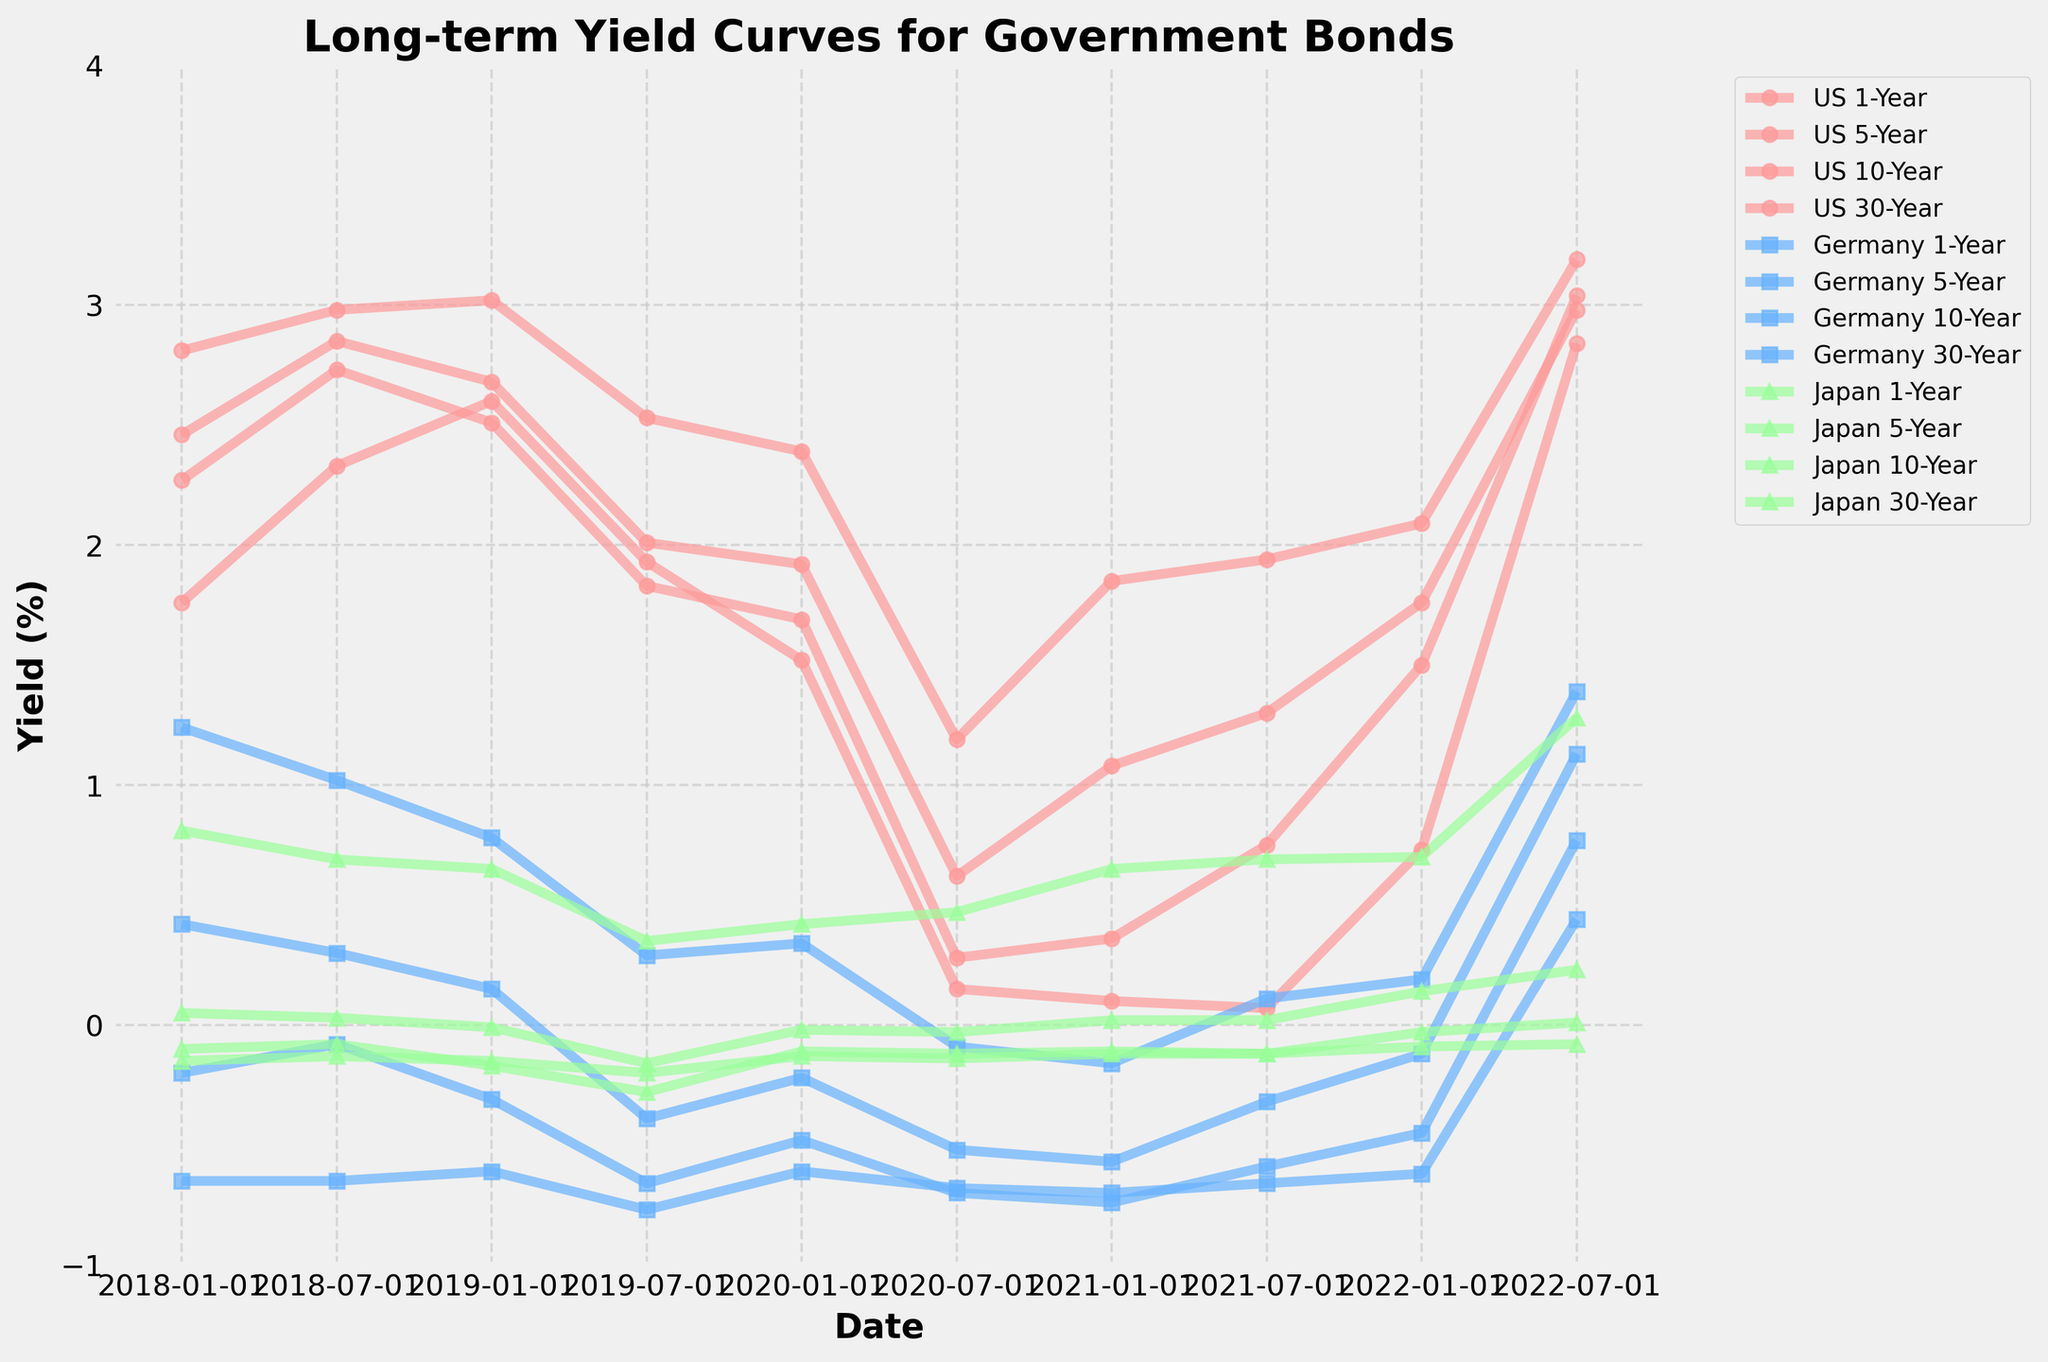How did the US 1-Year yield change from January 2020 to July 2022? To determine the change, find the yield for January 2020 (1.52%) and July 2022 (2.84%). Subtract the January 2020 value from the July 2022 value: 2.84% - 1.52% = 1.32%.
Answer: Increased by 1.32% In July 2021, which country's 30-Year bond had the highest yield? Check the 30-Year yield values for all countries: US (1.94%), Germany (0.11%), Japan (0.69%). The US has the highest value at 1.94%.
Answer: US Which bond had a negative yield for the majority of the recorded dates? Identify bonds with negative yields across most dates. Germany's bonds, especially the 1-Year (-0.65 to -0.70), had consistently negative yields.
Answer: Germany 1-Year Compare the yield of Japan 10-Year bonds between July 2018 and July 2022. Did it increase or decrease? The yields for Japan 10-Year bonds are 0.03% (July 2018) and 0.23% (July 2022). Compare these values to see that 0.23% > 0.03%, indicating an increase.
Answer: Increased What is the average yield of the US 10-Year bond from January 2018 to July 2022? Find the US 10-Year yields at each date, sum them, then divide by the number of dates: (2.46 + 2.85 + 2.68 + 2.01 + 1.92 + 0.62 + 1.08 + 1.30 + 1.76 + 2.98) / 10 = 1.866%.
Answer: 1.87% Which country had the greatest increase in 5-Year bond yields from January 2021 to July 2022? Calculate the yield change for each country: US (3.04 - 0.36 = 2.68), Germany (0.77 - (-0.74) = 1.51), Japan (0.01 - (-0.11) = 0.12). The US had the greatest increase of 2.68%.
Answer: US What is the trend of US 30-Year yields from January 2018 to July 2022? Analyze the data points for US 30-Year bonds: 2.81 (Jan 2018), 2.98 (Jul 2018), 3.02 (Jan 2019), 2.53 (Jul 2019), 2.39 (Jan 2020), 1.19 (Jul 2020), 1.85 (Jan 2021), 1.94 (Jul 2021), 2.09 (Jan 2022), 3.19 (Jul 2022). There is an overall decrease till mid-2020, followed by an increasing trend.
Answer: Decreasing then increasing On which date did Japan’s 1-Year bond reach its lowest yield, and what was the yield? Identify the lowest yield value for Japan 1-Year bonds across the dates. The lowest is -0.20% on July 2019.
Answer: July 2019, -0.20% How does Germany's 10-Year bond yield compare to Japan's 10-Year bond yield in January 2022? Compare Germany's 10-Year yield (-0.12%) with Japan's 10-Year yield (0.14%) in January 2022. Germany's is lower.
Answer: Germany's is lower What's the difference between the highest and lowest yields of US 1-Year bonds between January 2018 and July 2022? Find the highest (2.84% in Jul 2022) and lowest (0.07% in Jul 2021) US 1-Year yields. The difference is 2.84% - 0.07% = 2.77%.
Answer: 2.77% 